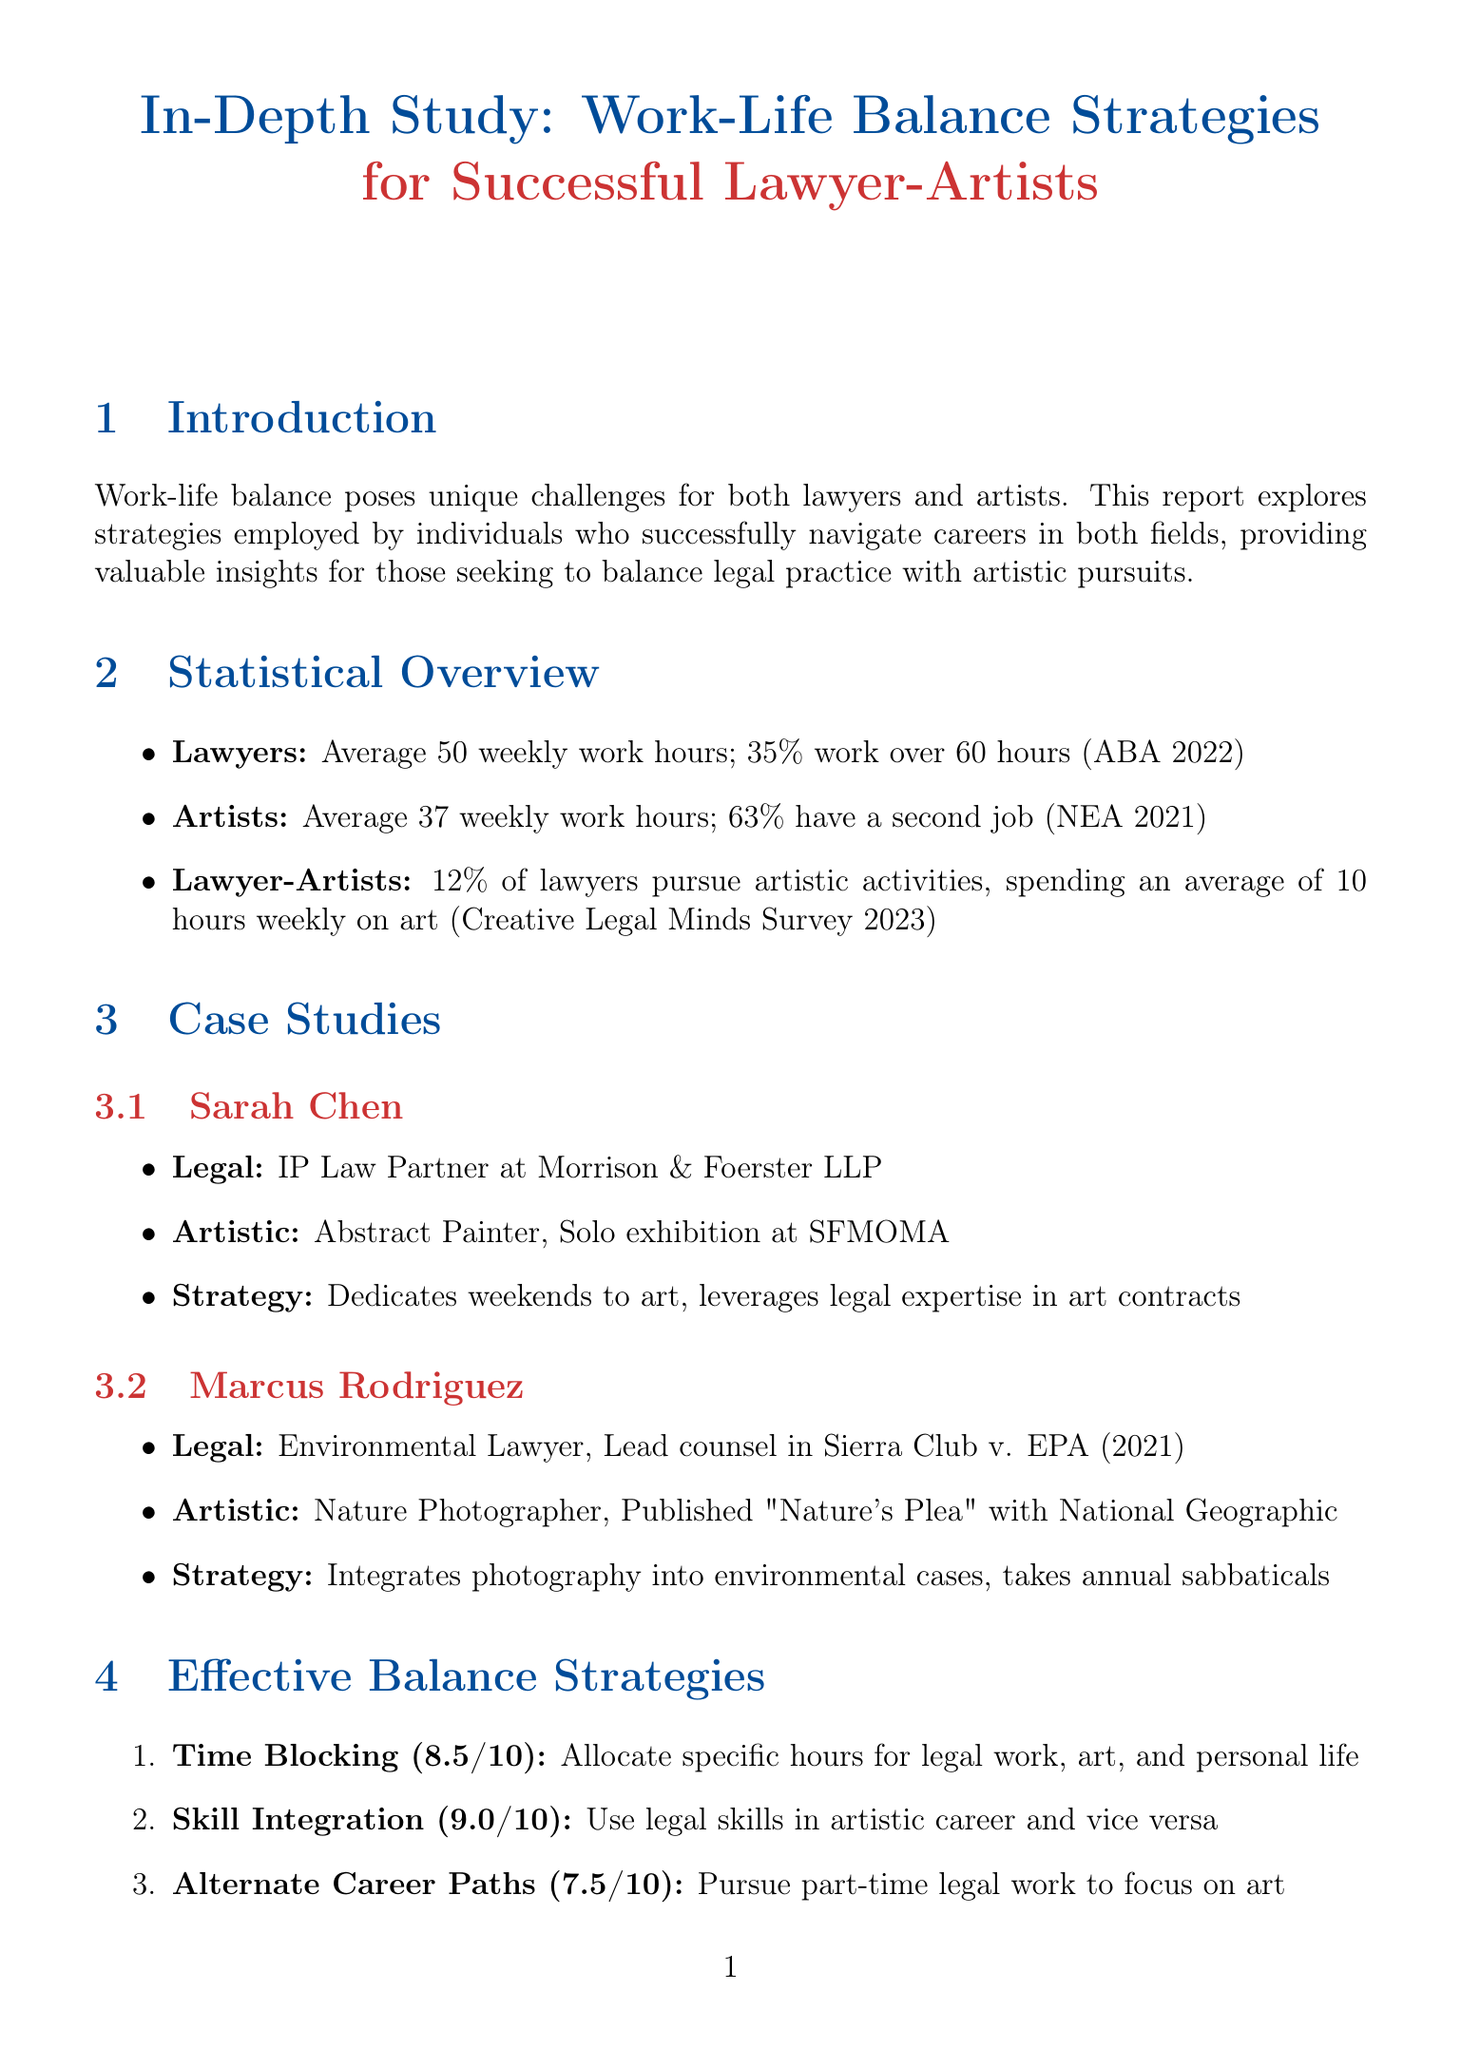what is the average weekly work hours for lawyers? The average weekly work hours for lawyers is provided in the statistical data section of the document.
Answer: 50 what percentage of lawyers work over 60 hours weekly? The percentage of lawyers working over 60 hours is specified in the statistical overview.
Answer: 35% who is the legal specialty of Sarah Chen? The document lists Sarah Chen's legal specialty in the case study section.
Answer: Intellectual Property Law what is the effectiveness rating of the Skill Integration strategy? The effectiveness ratings for various balance strategies are detailed in the effective balance strategies section.
Answer: 9.0 what challenge is associated with financial stability for lawyer-artists? The challenges faced by lawyer-artists are outlined in the challenges and solutions section, particularly related to financial issues.
Answer: Ensuring steady income what artistic pursuit does Marcus Rodriguez engage in? The case studies section provides details about Marcus Rodriguez's artistic pursuits.
Answer: Nature Photography what resource provides pro bono legal services for artists? The resources section mentions specific resources available for artists, including legal services.
Answer: Art Law Clinic at Yale Law School how many hours do lawyer-artists spend on art weekly on average? This statistic is found in the lawyer-artist hybrid careers section of the document.
Answer: 10 what is the strategy employed by Emily Tanaka for work-life balance? The effective balance strategies section includes examples of users implementing various strategies.
Answer: Time Blocking 